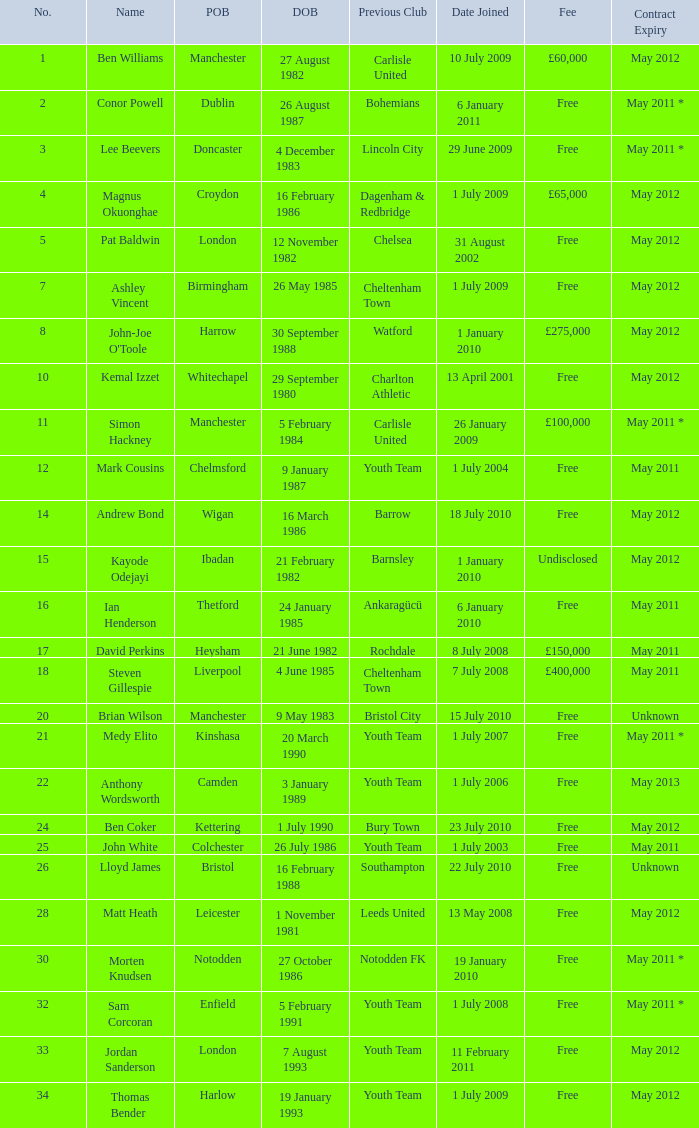How many date of birts are if the previous club is chelsea 1.0. 